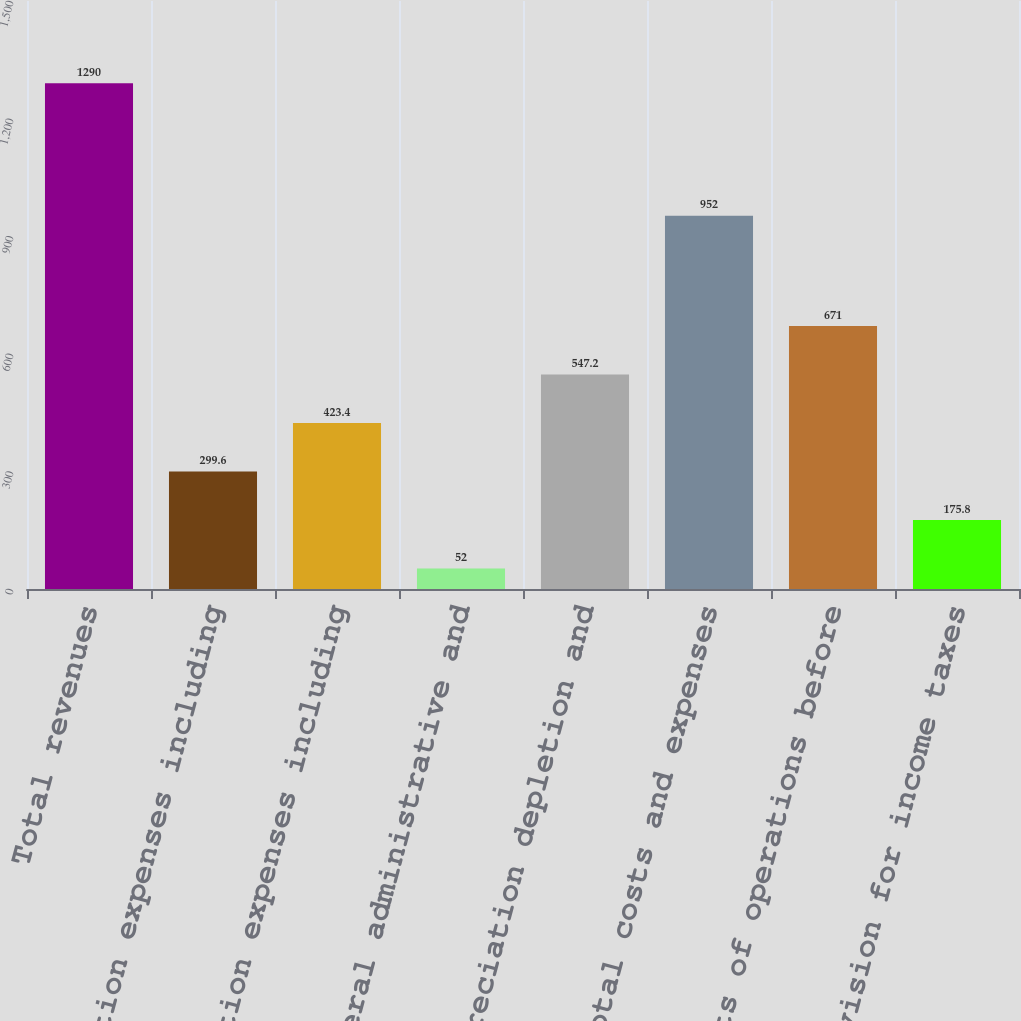<chart> <loc_0><loc_0><loc_500><loc_500><bar_chart><fcel>Total revenues<fcel>Production expenses including<fcel>Exploration expenses including<fcel>General administrative and<fcel>Depreciation depletion and<fcel>Total costs and expenses<fcel>Results of operations before<fcel>Provision for income taxes<nl><fcel>1290<fcel>299.6<fcel>423.4<fcel>52<fcel>547.2<fcel>952<fcel>671<fcel>175.8<nl></chart> 